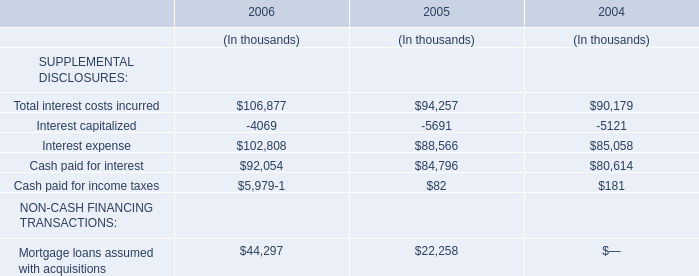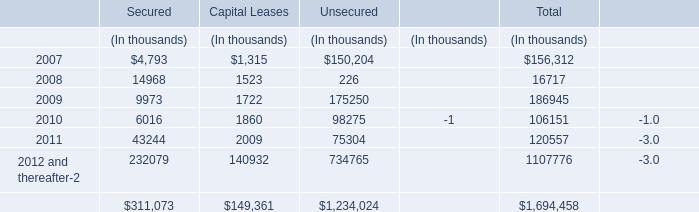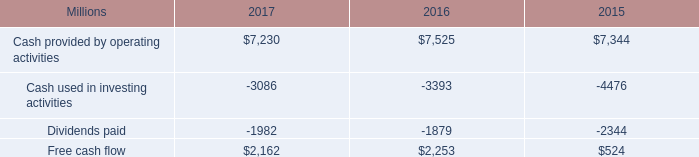what was the percentage change in free cash flow from 2016 to 2017? 
Computations: ((2162 - 2253) / 2253)
Answer: -0.04039. 